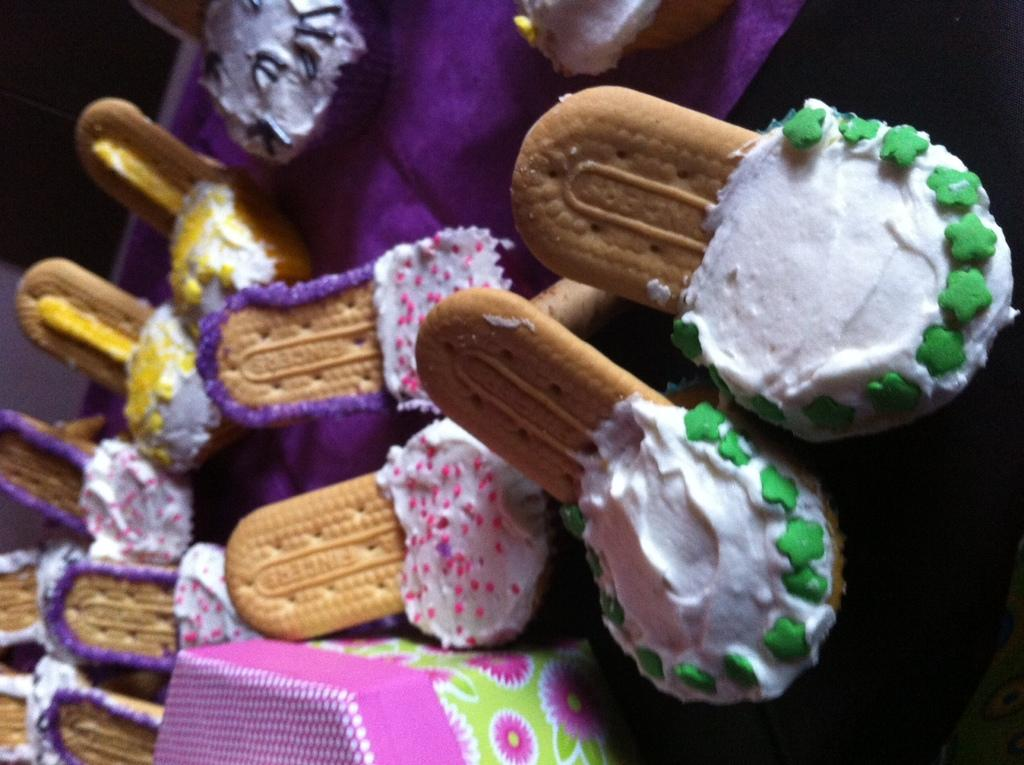What type of food items can be seen in the image? There are colorful food items in the image. What is the color of the surface in the image? The surface in the image is black and purple. Is there any smoke coming from the food items in the image? No, there is no smoke present in the image. What type of throne is visible in the image? There is no throne present in the image. 